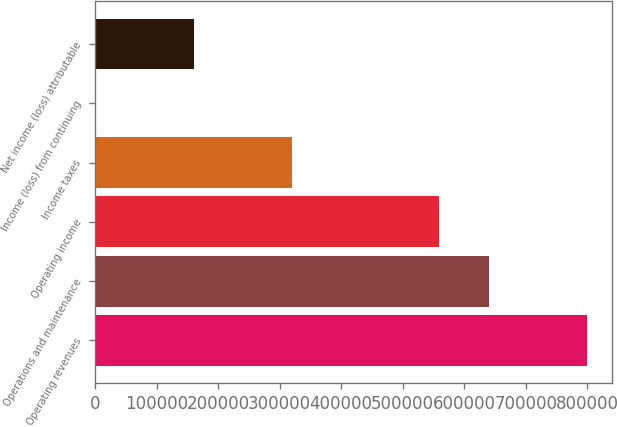Convert chart to OTSL. <chart><loc_0><loc_0><loc_500><loc_500><bar_chart><fcel>Operating revenues<fcel>Operations and maintenance<fcel>Operating income<fcel>Income taxes<fcel>Income (loss) from continuing<fcel>Net income (loss) attributable<nl><fcel>799799<fcel>639839<fcel>559860<fcel>319920<fcel>0.78<fcel>159960<nl></chart> 